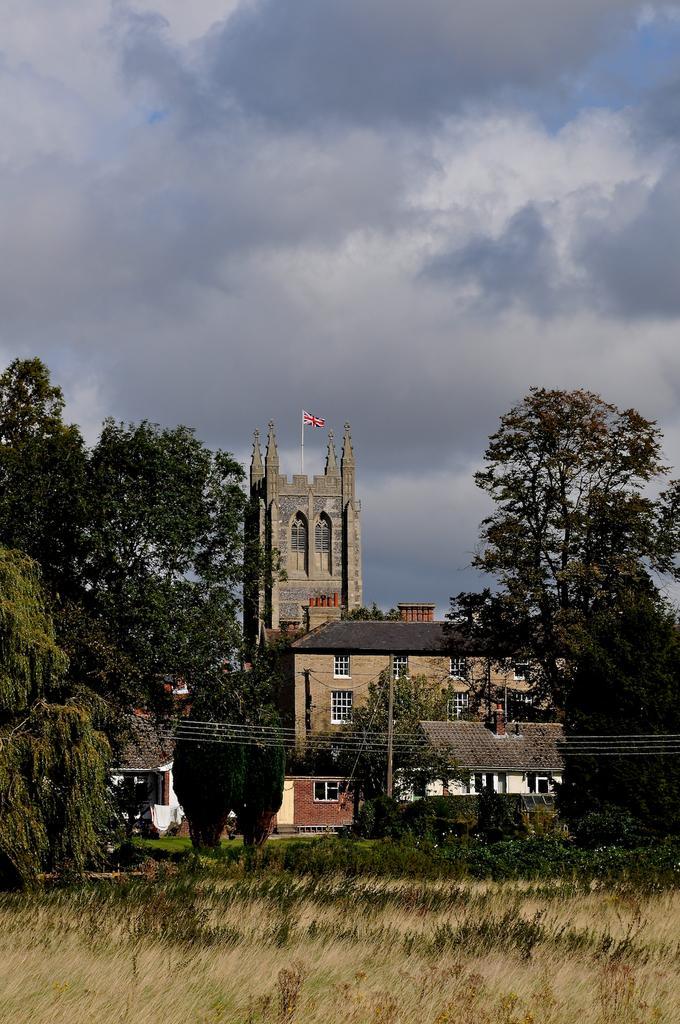Can you describe this image briefly? This is an outside view. At the bottom of the image I can see the grass. In the background there are some buildings and trees. On the top of the building there is a flag which is red color. On the top of the image I can see the sky and clouds. In the foreground I can see a pole along with the wires. 